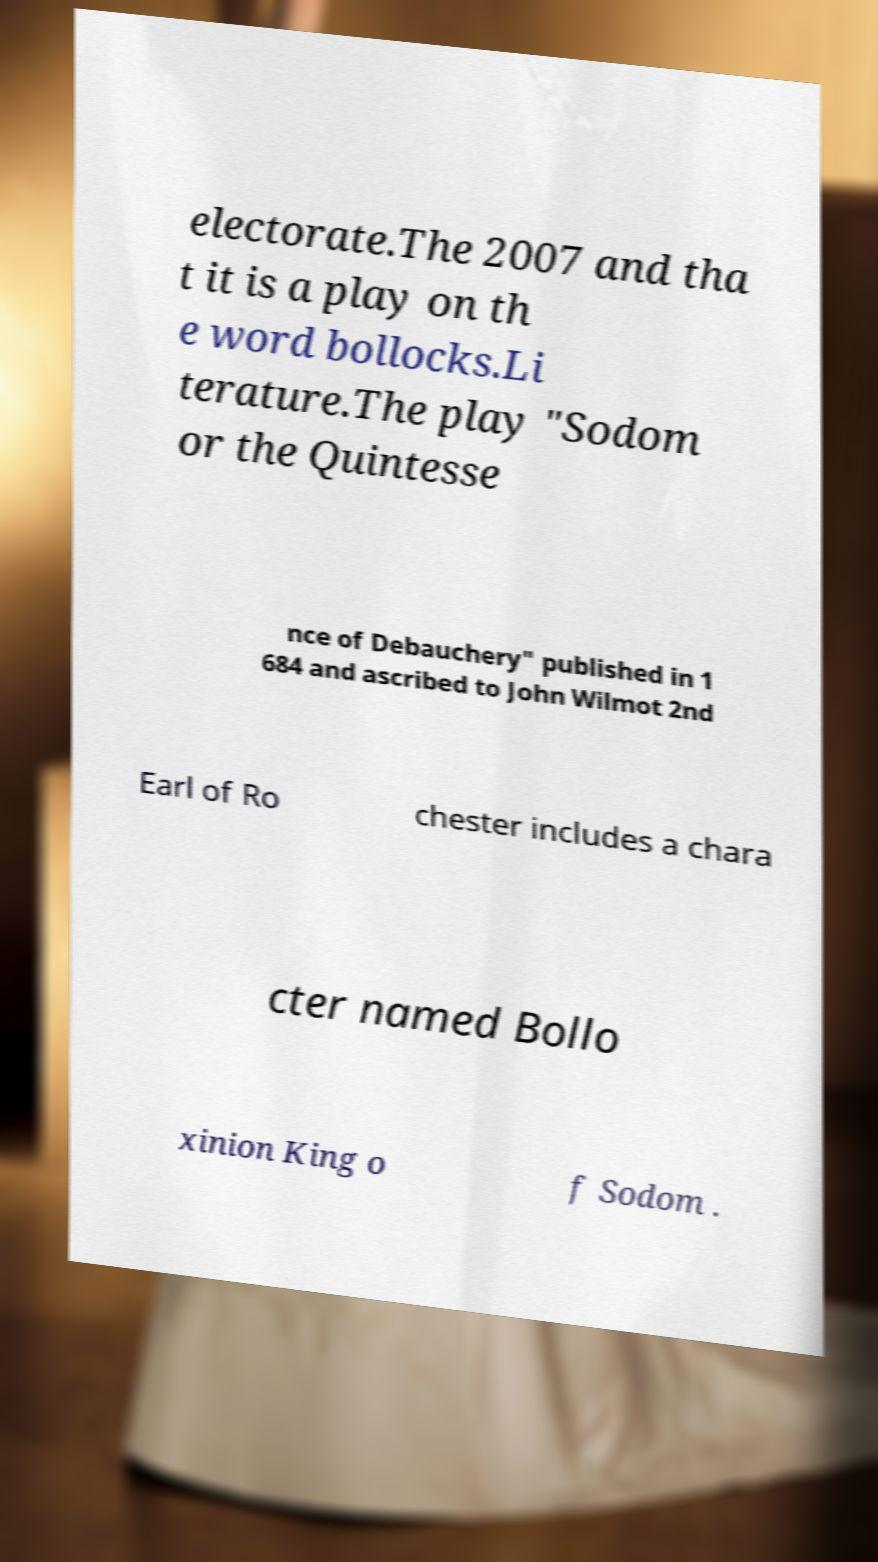Please identify and transcribe the text found in this image. electorate.The 2007 and tha t it is a play on th e word bollocks.Li terature.The play "Sodom or the Quintesse nce of Debauchery" published in 1 684 and ascribed to John Wilmot 2nd Earl of Ro chester includes a chara cter named Bollo xinion King o f Sodom . 